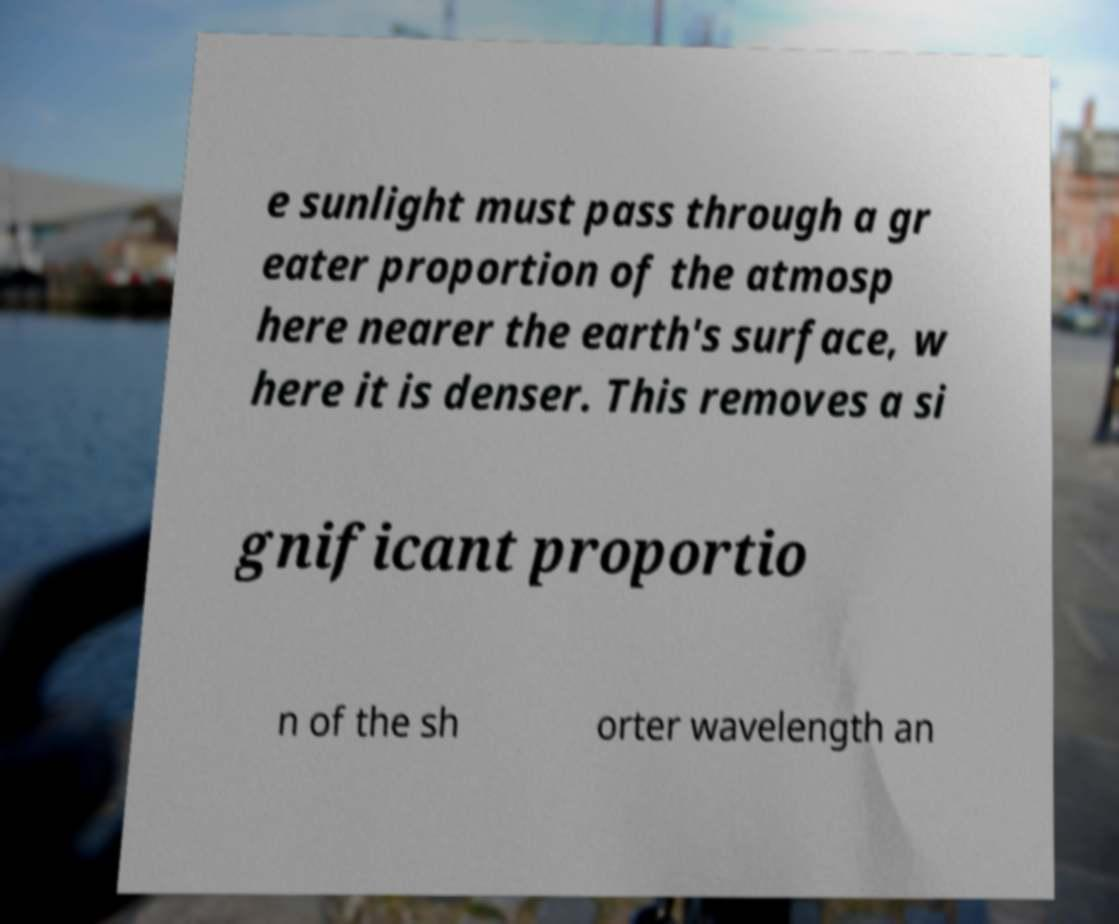Can you accurately transcribe the text from the provided image for me? e sunlight must pass through a gr eater proportion of the atmosp here nearer the earth's surface, w here it is denser. This removes a si gnificant proportio n of the sh orter wavelength an 